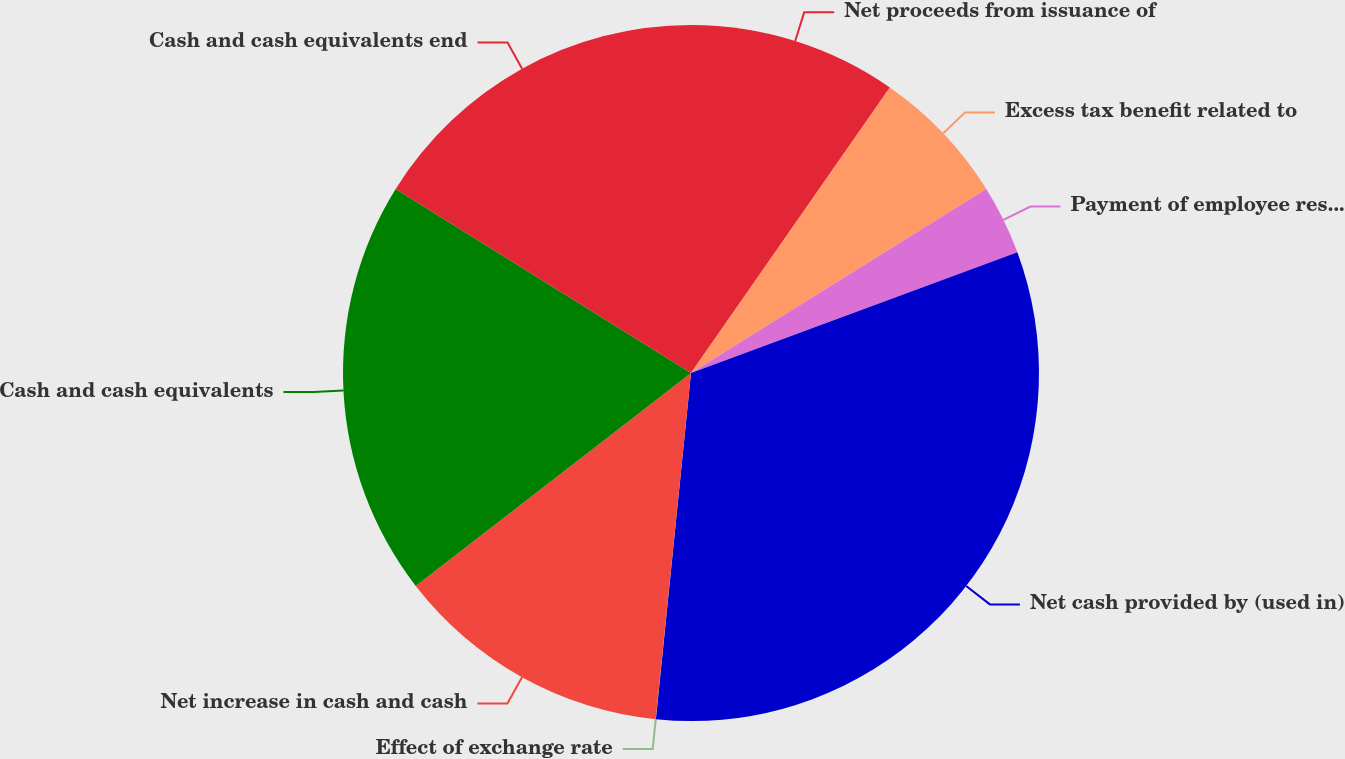Convert chart. <chart><loc_0><loc_0><loc_500><loc_500><pie_chart><fcel>Net proceeds from issuance of<fcel>Excess tax benefit related to<fcel>Payment of employee restricted<fcel>Net cash provided by (used in)<fcel>Effect of exchange rate<fcel>Net increase in cash and cash<fcel>Cash and cash equivalents<fcel>Cash and cash equivalents end<nl><fcel>9.68%<fcel>6.45%<fcel>3.23%<fcel>32.25%<fcel>0.01%<fcel>12.9%<fcel>19.35%<fcel>16.13%<nl></chart> 